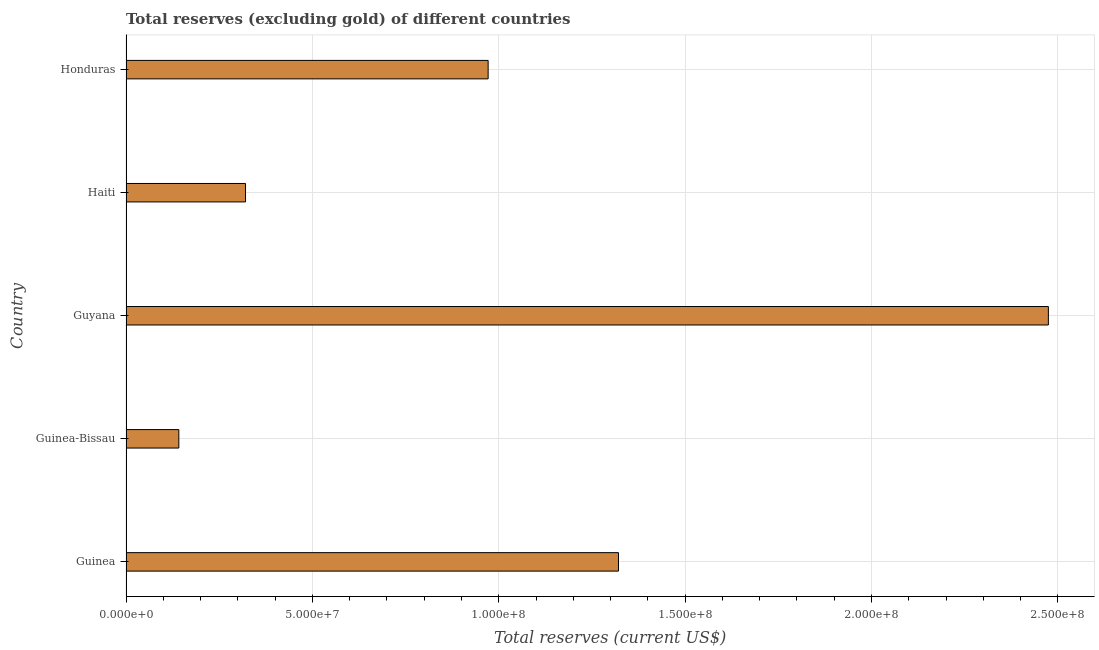Does the graph contain any zero values?
Your response must be concise. No. Does the graph contain grids?
Your response must be concise. Yes. What is the title of the graph?
Offer a terse response. Total reserves (excluding gold) of different countries. What is the label or title of the X-axis?
Ensure brevity in your answer.  Total reserves (current US$). What is the label or title of the Y-axis?
Provide a short and direct response. Country. What is the total reserves (excluding gold) in Guyana?
Your answer should be very brief. 2.47e+08. Across all countries, what is the maximum total reserves (excluding gold)?
Give a very brief answer. 2.47e+08. Across all countries, what is the minimum total reserves (excluding gold)?
Give a very brief answer. 1.42e+07. In which country was the total reserves (excluding gold) maximum?
Offer a very short reply. Guyana. In which country was the total reserves (excluding gold) minimum?
Ensure brevity in your answer.  Guinea-Bissau. What is the sum of the total reserves (excluding gold)?
Offer a terse response. 5.23e+08. What is the difference between the total reserves (excluding gold) in Guyana and Haiti?
Your answer should be very brief. 2.15e+08. What is the average total reserves (excluding gold) per country?
Make the answer very short. 1.05e+08. What is the median total reserves (excluding gold)?
Make the answer very short. 9.72e+07. In how many countries, is the total reserves (excluding gold) greater than 90000000 US$?
Your response must be concise. 3. What is the ratio of the total reserves (excluding gold) in Guinea-Bissau to that in Honduras?
Make the answer very short. 0.15. What is the difference between the highest and the second highest total reserves (excluding gold)?
Ensure brevity in your answer.  1.15e+08. What is the difference between the highest and the lowest total reserves (excluding gold)?
Your answer should be very brief. 2.33e+08. In how many countries, is the total reserves (excluding gold) greater than the average total reserves (excluding gold) taken over all countries?
Provide a succinct answer. 2. Are all the bars in the graph horizontal?
Make the answer very short. Yes. Are the values on the major ticks of X-axis written in scientific E-notation?
Ensure brevity in your answer.  Yes. What is the Total reserves (current US$) of Guinea?
Give a very brief answer. 1.32e+08. What is the Total reserves (current US$) of Guinea-Bissau?
Your answer should be compact. 1.42e+07. What is the Total reserves (current US$) of Guyana?
Your response must be concise. 2.47e+08. What is the Total reserves (current US$) of Haiti?
Keep it short and to the point. 3.21e+07. What is the Total reserves (current US$) of Honduras?
Offer a terse response. 9.72e+07. What is the difference between the Total reserves (current US$) in Guinea and Guinea-Bissau?
Your answer should be very brief. 1.18e+08. What is the difference between the Total reserves (current US$) in Guinea and Guyana?
Provide a short and direct response. -1.15e+08. What is the difference between the Total reserves (current US$) in Guinea and Haiti?
Ensure brevity in your answer.  1.00e+08. What is the difference between the Total reserves (current US$) in Guinea and Honduras?
Provide a short and direct response. 3.50e+07. What is the difference between the Total reserves (current US$) in Guinea-Bissau and Guyana?
Keep it short and to the point. -2.33e+08. What is the difference between the Total reserves (current US$) in Guinea-Bissau and Haiti?
Your answer should be compact. -1.79e+07. What is the difference between the Total reserves (current US$) in Guinea-Bissau and Honduras?
Your response must be concise. -8.30e+07. What is the difference between the Total reserves (current US$) in Guyana and Haiti?
Make the answer very short. 2.15e+08. What is the difference between the Total reserves (current US$) in Guyana and Honduras?
Your answer should be compact. 1.50e+08. What is the difference between the Total reserves (current US$) in Haiti and Honduras?
Offer a very short reply. -6.51e+07. What is the ratio of the Total reserves (current US$) in Guinea to that in Guinea-Bissau?
Provide a short and direct response. 9.33. What is the ratio of the Total reserves (current US$) in Guinea to that in Guyana?
Offer a very short reply. 0.53. What is the ratio of the Total reserves (current US$) in Guinea to that in Haiti?
Your answer should be compact. 4.12. What is the ratio of the Total reserves (current US$) in Guinea to that in Honduras?
Ensure brevity in your answer.  1.36. What is the ratio of the Total reserves (current US$) in Guinea-Bissau to that in Guyana?
Provide a succinct answer. 0.06. What is the ratio of the Total reserves (current US$) in Guinea-Bissau to that in Haiti?
Provide a succinct answer. 0.44. What is the ratio of the Total reserves (current US$) in Guinea-Bissau to that in Honduras?
Offer a very short reply. 0.15. What is the ratio of the Total reserves (current US$) in Guyana to that in Haiti?
Your answer should be compact. 7.72. What is the ratio of the Total reserves (current US$) in Guyana to that in Honduras?
Your answer should be compact. 2.55. What is the ratio of the Total reserves (current US$) in Haiti to that in Honduras?
Give a very brief answer. 0.33. 